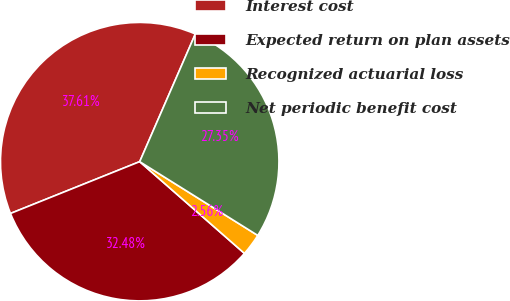<chart> <loc_0><loc_0><loc_500><loc_500><pie_chart><fcel>Interest cost<fcel>Expected return on plan assets<fcel>Recognized actuarial loss<fcel>Net periodic benefit cost<nl><fcel>37.61%<fcel>32.48%<fcel>2.56%<fcel>27.35%<nl></chart> 